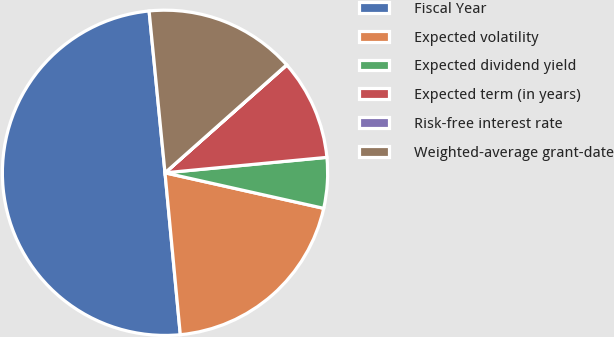<chart> <loc_0><loc_0><loc_500><loc_500><pie_chart><fcel>Fiscal Year<fcel>Expected volatility<fcel>Expected dividend yield<fcel>Expected term (in years)<fcel>Risk-free interest rate<fcel>Weighted-average grant-date<nl><fcel>49.93%<fcel>19.99%<fcel>5.02%<fcel>10.01%<fcel>0.03%<fcel>15.0%<nl></chart> 